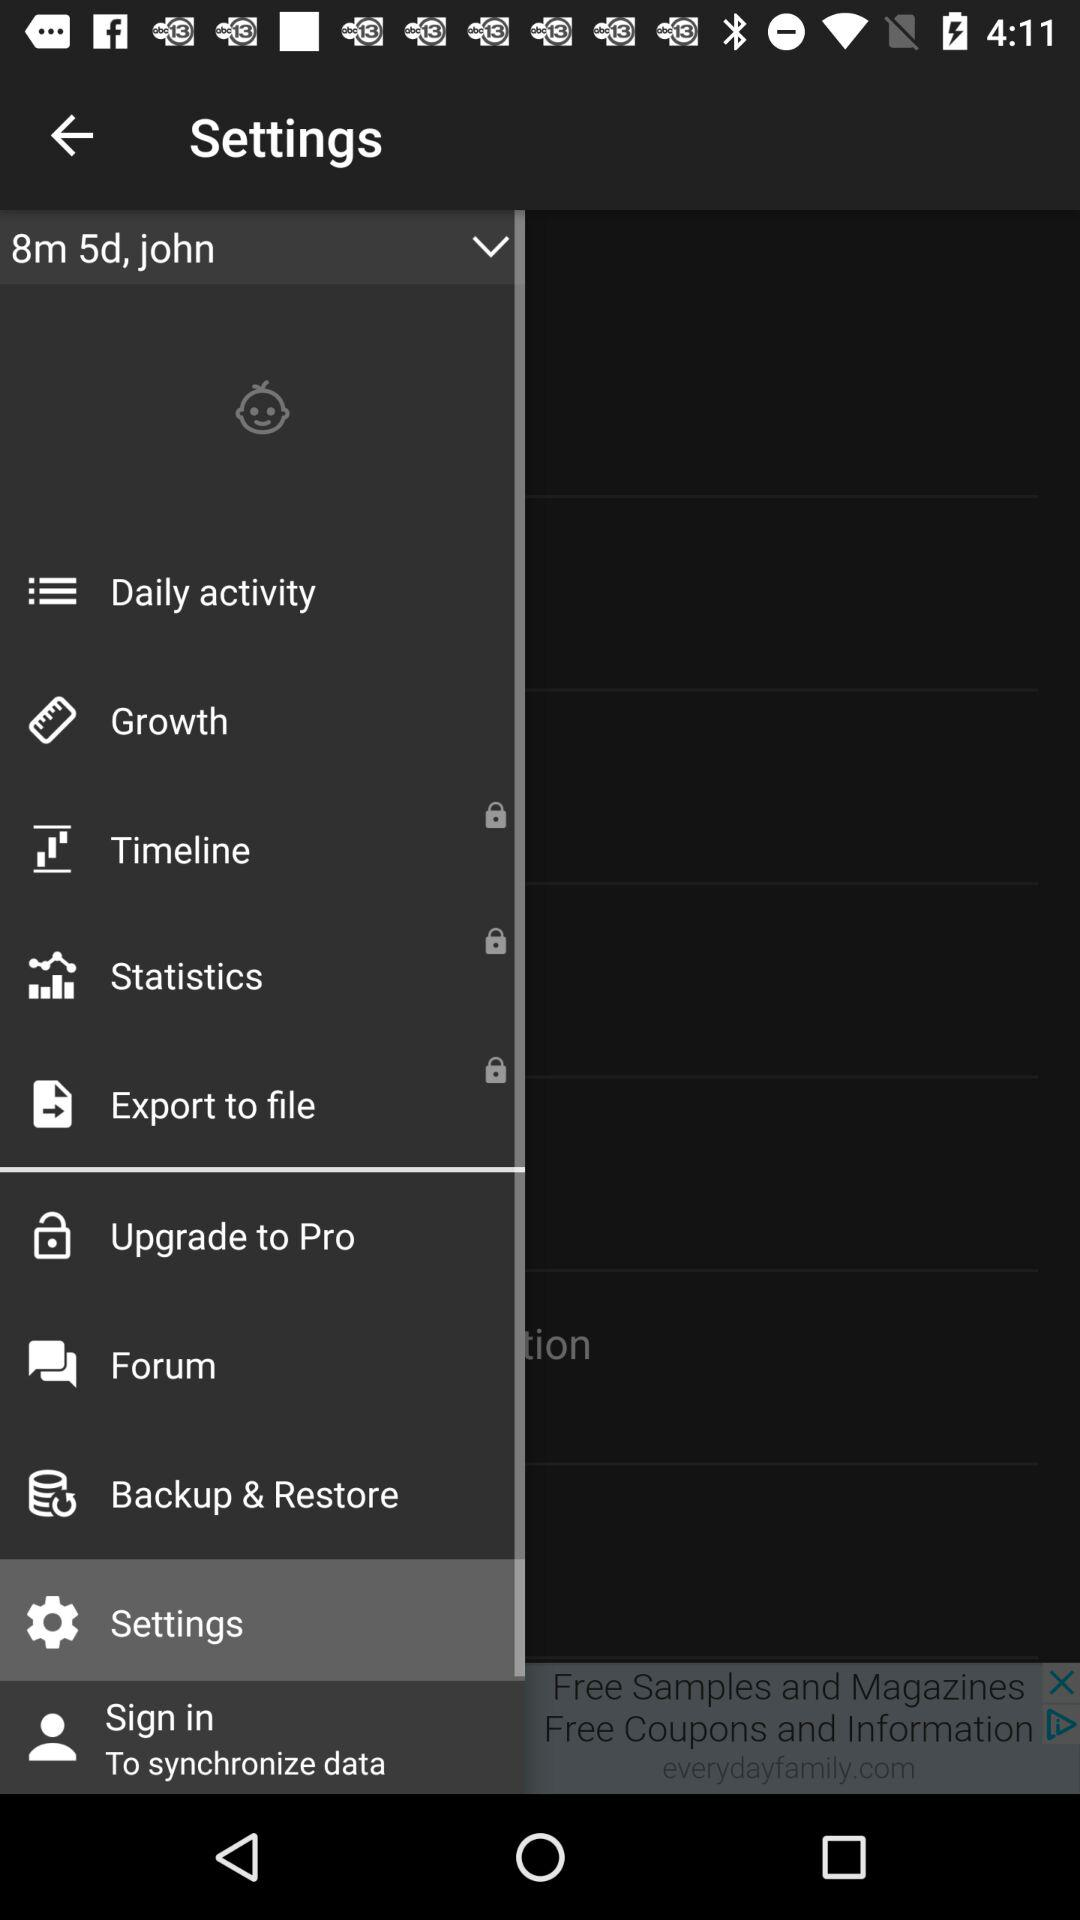How many months ago did the user join this application? The user joined this application 8 months and 5 days ago. 